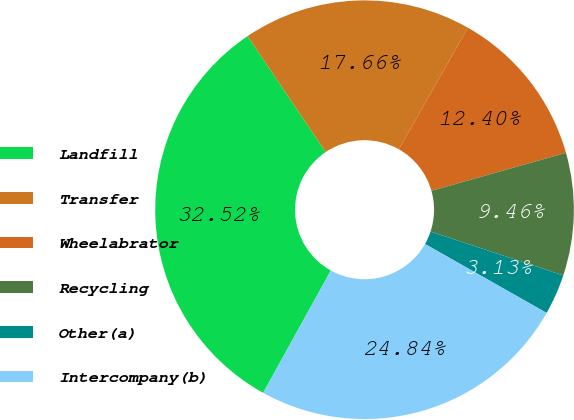<chart> <loc_0><loc_0><loc_500><loc_500><pie_chart><fcel>Landfill<fcel>Transfer<fcel>Wheelabrator<fcel>Recycling<fcel>Other(a)<fcel>Intercompany(b)<nl><fcel>32.52%<fcel>17.66%<fcel>12.4%<fcel>9.46%<fcel>3.13%<fcel>24.84%<nl></chart> 